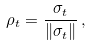Convert formula to latex. <formula><loc_0><loc_0><loc_500><loc_500>\rho _ { t } = \frac { \sigma _ { t } } { \left \| \sigma _ { t } \right \| } \, ,</formula> 